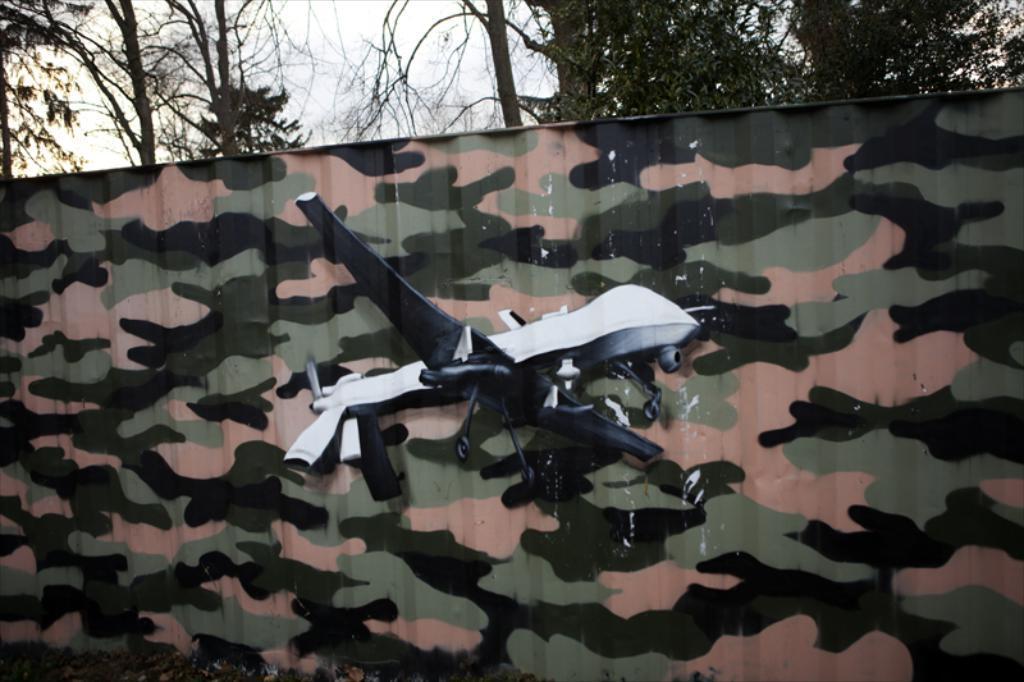In one or two sentences, can you explain what this image depicts? This is the picture of a toy which is plane shape and it is in front of the cloth and behind there are some trees. 